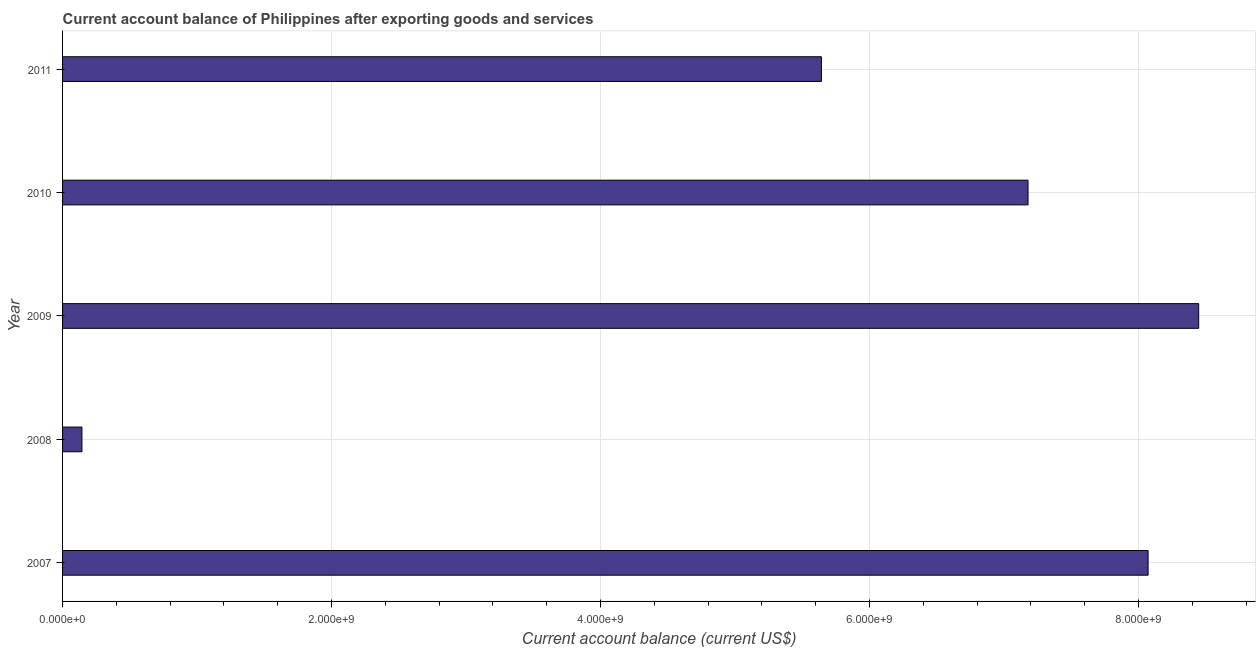Does the graph contain any zero values?
Offer a terse response. No. What is the title of the graph?
Your response must be concise. Current account balance of Philippines after exporting goods and services. What is the label or title of the X-axis?
Make the answer very short. Current account balance (current US$). What is the label or title of the Y-axis?
Provide a succinct answer. Year. What is the current account balance in 2009?
Provide a short and direct response. 8.45e+09. Across all years, what is the maximum current account balance?
Offer a very short reply. 8.45e+09. Across all years, what is the minimum current account balance?
Offer a very short reply. 1.44e+08. In which year was the current account balance maximum?
Ensure brevity in your answer.  2009. What is the sum of the current account balance?
Keep it short and to the point. 2.95e+1. What is the difference between the current account balance in 2007 and 2009?
Your answer should be compact. -3.76e+08. What is the average current account balance per year?
Make the answer very short. 5.90e+09. What is the median current account balance?
Ensure brevity in your answer.  7.18e+09. What is the ratio of the current account balance in 2008 to that in 2010?
Provide a succinct answer. 0.02. Is the difference between the current account balance in 2007 and 2009 greater than the difference between any two years?
Give a very brief answer. No. What is the difference between the highest and the second highest current account balance?
Make the answer very short. 3.76e+08. Is the sum of the current account balance in 2009 and 2011 greater than the maximum current account balance across all years?
Your answer should be very brief. Yes. What is the difference between the highest and the lowest current account balance?
Your answer should be very brief. 8.30e+09. In how many years, is the current account balance greater than the average current account balance taken over all years?
Ensure brevity in your answer.  3. How many bars are there?
Provide a short and direct response. 5. Are all the bars in the graph horizontal?
Offer a very short reply. Yes. How many years are there in the graph?
Provide a short and direct response. 5. What is the difference between two consecutive major ticks on the X-axis?
Provide a succinct answer. 2.00e+09. What is the Current account balance (current US$) of 2007?
Offer a very short reply. 8.07e+09. What is the Current account balance (current US$) of 2008?
Provide a succinct answer. 1.44e+08. What is the Current account balance (current US$) of 2009?
Your answer should be compact. 8.45e+09. What is the Current account balance (current US$) of 2010?
Your answer should be compact. 7.18e+09. What is the Current account balance (current US$) in 2011?
Keep it short and to the point. 5.64e+09. What is the difference between the Current account balance (current US$) in 2007 and 2008?
Your answer should be very brief. 7.93e+09. What is the difference between the Current account balance (current US$) in 2007 and 2009?
Provide a short and direct response. -3.76e+08. What is the difference between the Current account balance (current US$) in 2007 and 2010?
Provide a short and direct response. 8.93e+08. What is the difference between the Current account balance (current US$) in 2007 and 2011?
Your response must be concise. 2.43e+09. What is the difference between the Current account balance (current US$) in 2008 and 2009?
Your answer should be very brief. -8.30e+09. What is the difference between the Current account balance (current US$) in 2008 and 2010?
Your answer should be very brief. -7.04e+09. What is the difference between the Current account balance (current US$) in 2008 and 2011?
Provide a succinct answer. -5.50e+09. What is the difference between the Current account balance (current US$) in 2009 and 2010?
Ensure brevity in your answer.  1.27e+09. What is the difference between the Current account balance (current US$) in 2009 and 2011?
Ensure brevity in your answer.  2.81e+09. What is the difference between the Current account balance (current US$) in 2010 and 2011?
Offer a very short reply. 1.54e+09. What is the ratio of the Current account balance (current US$) in 2007 to that in 2008?
Give a very brief answer. 56.05. What is the ratio of the Current account balance (current US$) in 2007 to that in 2009?
Ensure brevity in your answer.  0.95. What is the ratio of the Current account balance (current US$) in 2007 to that in 2010?
Keep it short and to the point. 1.12. What is the ratio of the Current account balance (current US$) in 2007 to that in 2011?
Your answer should be very brief. 1.43. What is the ratio of the Current account balance (current US$) in 2008 to that in 2009?
Keep it short and to the point. 0.02. What is the ratio of the Current account balance (current US$) in 2008 to that in 2011?
Keep it short and to the point. 0.03. What is the ratio of the Current account balance (current US$) in 2009 to that in 2010?
Make the answer very short. 1.18. What is the ratio of the Current account balance (current US$) in 2009 to that in 2011?
Provide a succinct answer. 1.5. What is the ratio of the Current account balance (current US$) in 2010 to that in 2011?
Offer a very short reply. 1.27. 